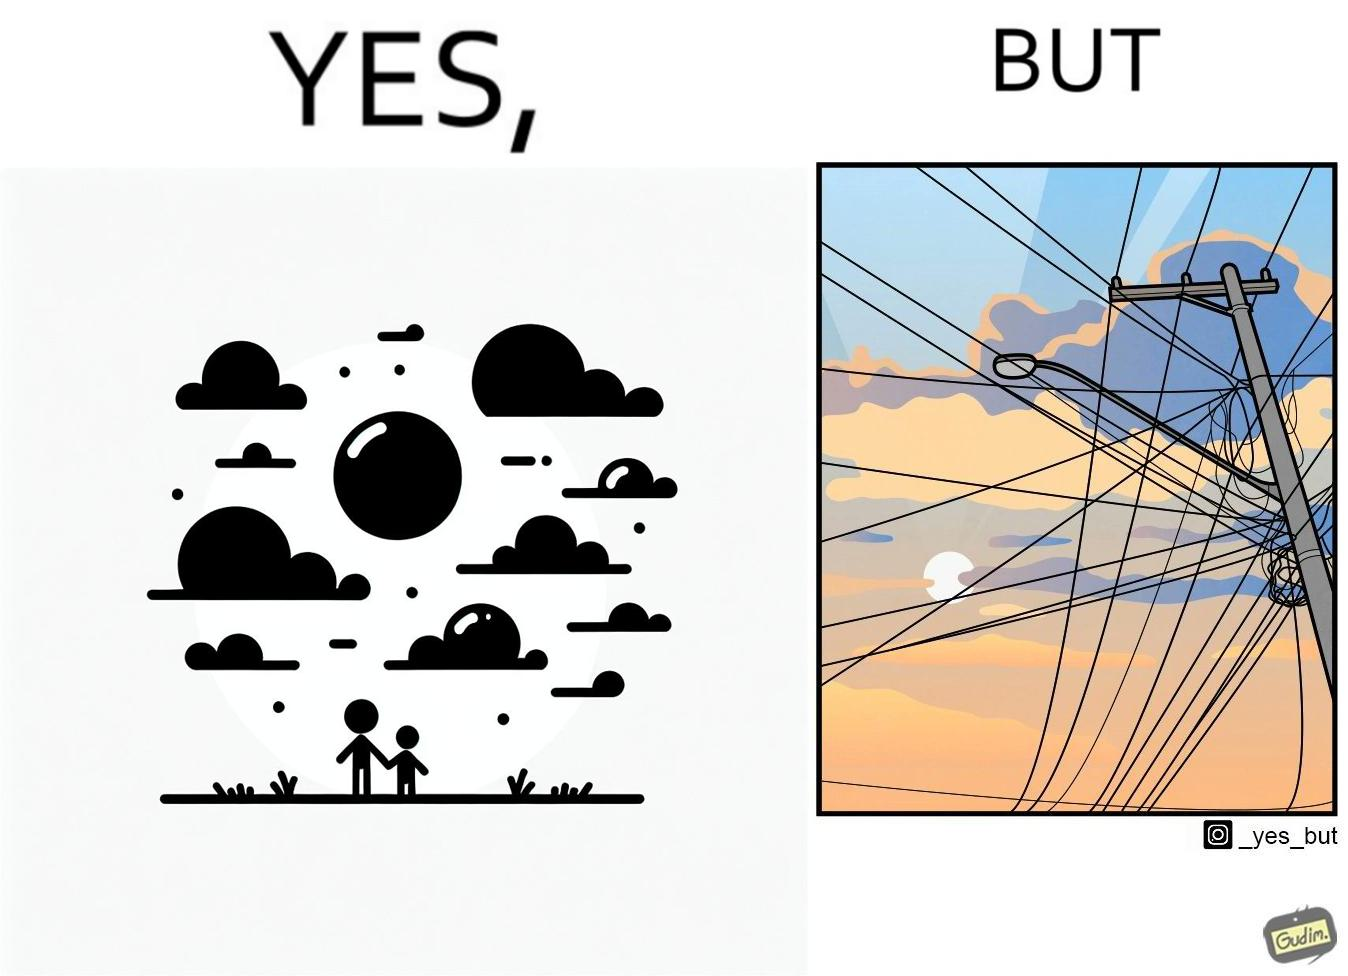Is this a satirical image? Yes, this image is satirical. 